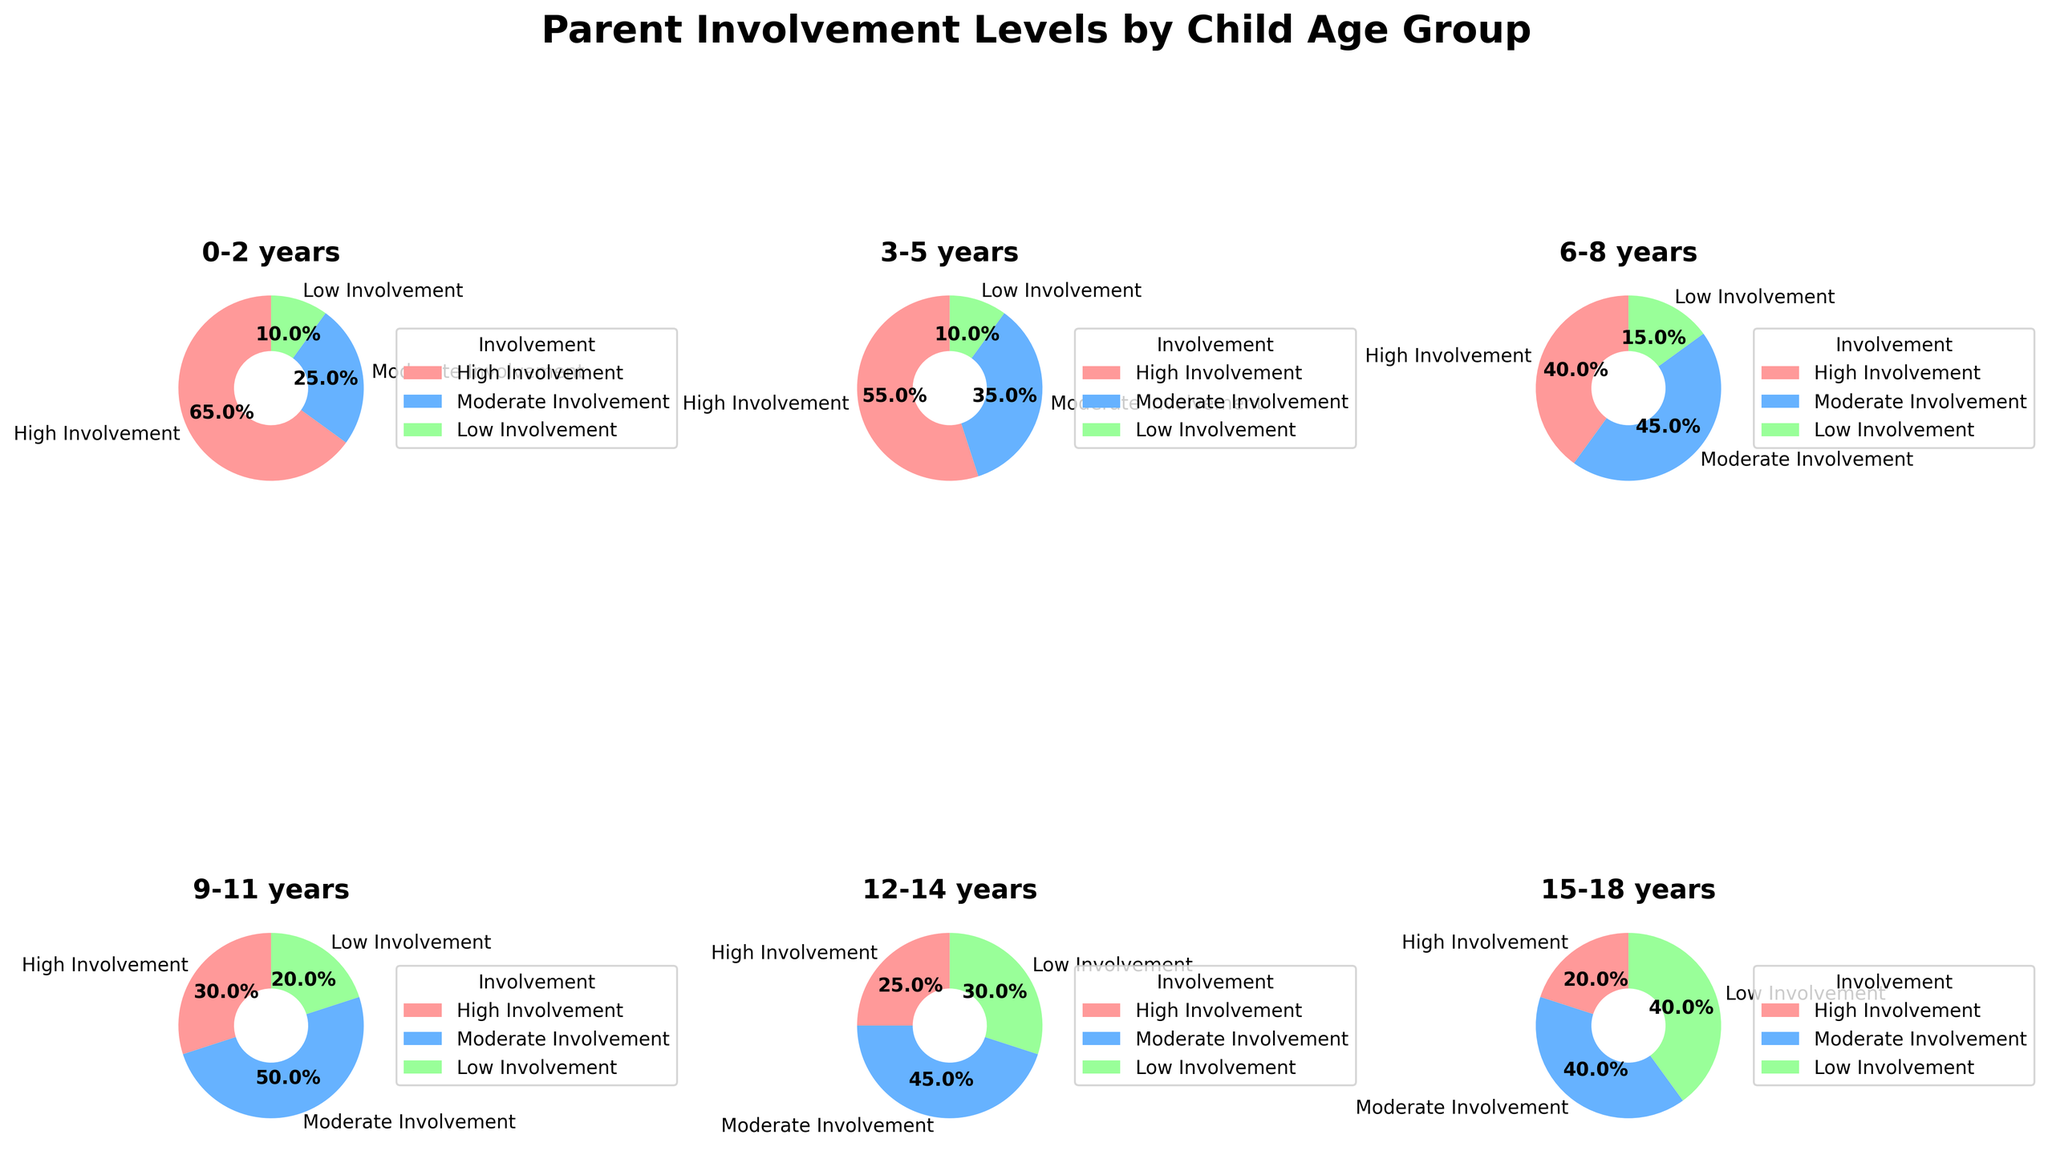What is the age group with the lowest parent involvement? Look at the pie chart for each age group and identify the group with the smallest percentage for 'Low Involvement'. The age group 0-2 years has the smallest slice for 'Low Involvement', at 10%.
Answer: 0-2 years Which age group has the highest percentage of parents with high involvement? Examine the slices labeled 'High Involvement' across all pie charts. The chart for ages 0-2 years has the largest slice, with 65% in 'High Involvement'.
Answer: 0-2 years Compare the 'High Involvement' and 'Low Involvement' percentages for the 9-11 years age group. What is the difference between them? For the age group 9-11 years, 'High Involvement' is 30% and 'Low Involvement' is 20%. The difference is calculated as 30% - 20%.
Answer: 10% Which age group shows an equal proportion of 'Moderate Involvement' and 'Low Involvement'? Check the pie charts for each age group to find equal proportions for 'Moderate Involvement' and 'Low Involvement'. The 15-18 years age group shows 40% for both categories.
Answer: 15-18 years For the 6-8 years age group, what is the sum of 'Moderate Involvement' and 'Low Involvement' percentages? Look at the 'Moderate Involvement' and 'Low Involvement' slices in the 6-8 years pie chart. Sum these values: 45% + 15% = 60%.
Answer: 60% Among all age groups, which one has the highest percentage of 'Moderate Involvement'? Identify the largest slice labeled 'Moderate Involvement' in any pie chart. The 9-11 years age group has the highest percentage of 'Moderate Involvement' at 50%.
Answer: 9-11 years What is the trend in 'High Involvement' as the child's age increases? Observe the 'High Involvement' percentage as you move from younger to older age groups. The percentage decreases from 65% in the 0-2 years group to 20% in the 15-18 years group.
Answer: Decreases 